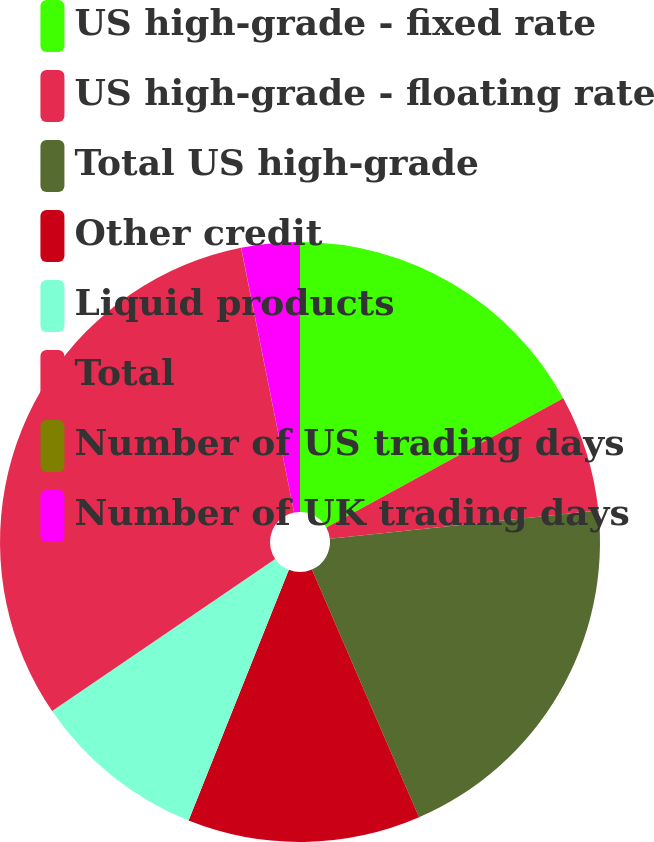Convert chart to OTSL. <chart><loc_0><loc_0><loc_500><loc_500><pie_chart><fcel>US high-grade - fixed rate<fcel>US high-grade - floating rate<fcel>Total US high-grade<fcel>Other credit<fcel>Liquid products<fcel>Total<fcel>Number of US trading days<fcel>Number of UK trading days<nl><fcel>17.04%<fcel>6.28%<fcel>20.18%<fcel>12.55%<fcel>9.42%<fcel>31.37%<fcel>0.01%<fcel>3.14%<nl></chart> 